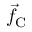<formula> <loc_0><loc_0><loc_500><loc_500>\vec { f } _ { C }</formula> 